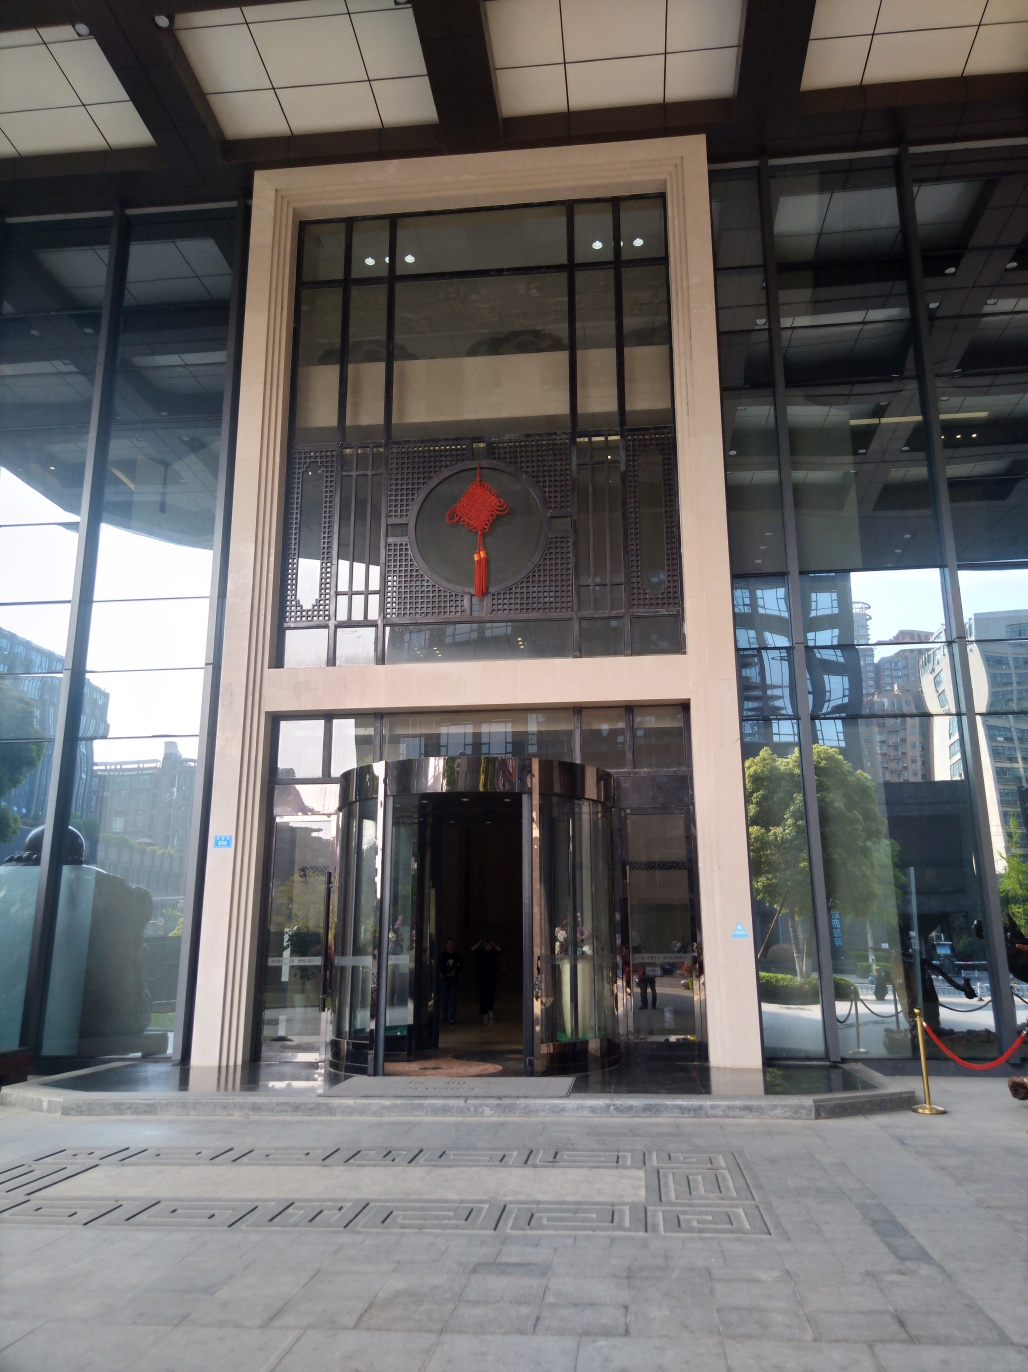What might be the significance of the circular emblem on the building? The circular emblem, often referred to as a 'bi' disc, is a traditional Chinese symbol that typically represents the sky and eternity. Its placement on the building could symbolize a connection between the past and present, paying homage to historical influences while maintaining a modern design. 